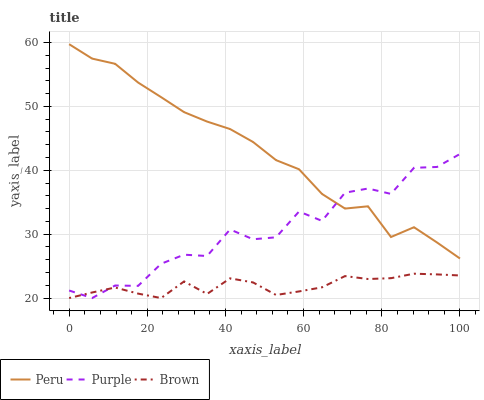Does Peru have the minimum area under the curve?
Answer yes or no. No. Does Brown have the maximum area under the curve?
Answer yes or no. No. Is Peru the smoothest?
Answer yes or no. No. Is Peru the roughest?
Answer yes or no. No. Does Peru have the lowest value?
Answer yes or no. No. Does Brown have the highest value?
Answer yes or no. No. Is Brown less than Peru?
Answer yes or no. Yes. Is Peru greater than Brown?
Answer yes or no. Yes. Does Brown intersect Peru?
Answer yes or no. No. 